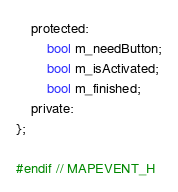<code> <loc_0><loc_0><loc_500><loc_500><_C_>    protected:
        bool m_needButton;
        bool m_isActivated;
        bool m_finished;
    private:
};

#endif // MAPEVENT_H
</code> 